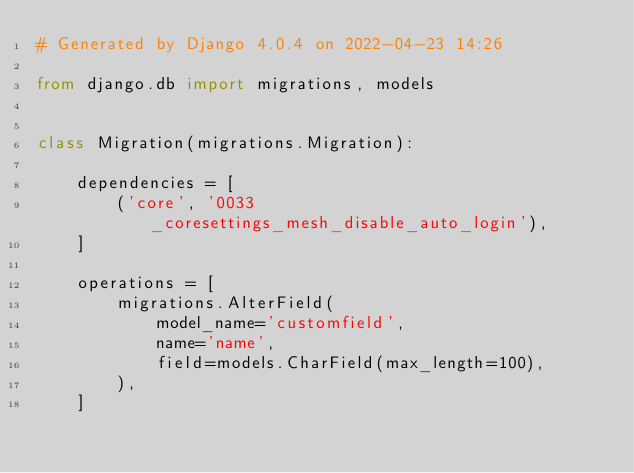<code> <loc_0><loc_0><loc_500><loc_500><_Python_># Generated by Django 4.0.4 on 2022-04-23 14:26

from django.db import migrations, models


class Migration(migrations.Migration):

    dependencies = [
        ('core', '0033_coresettings_mesh_disable_auto_login'),
    ]

    operations = [
        migrations.AlterField(
            model_name='customfield',
            name='name',
            field=models.CharField(max_length=100),
        ),
    ]
</code> 